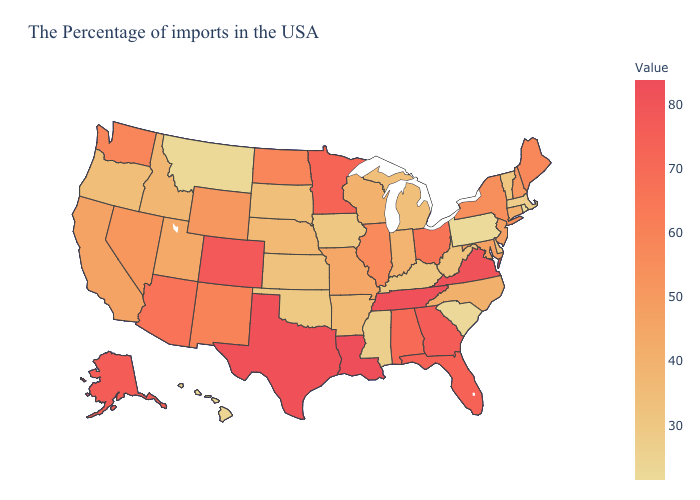Among the states that border Wyoming , does Utah have the lowest value?
Answer briefly. No. Does Alaska have a lower value than Louisiana?
Concise answer only. Yes. Does New Jersey have the lowest value in the Northeast?
Concise answer only. No. Is the legend a continuous bar?
Quick response, please. Yes. Is the legend a continuous bar?
Write a very short answer. Yes. Which states hav the highest value in the Northeast?
Keep it brief. Maine. Does South Carolina have the lowest value in the South?
Be succinct. Yes. Does Texas have the lowest value in the South?
Quick response, please. No. 